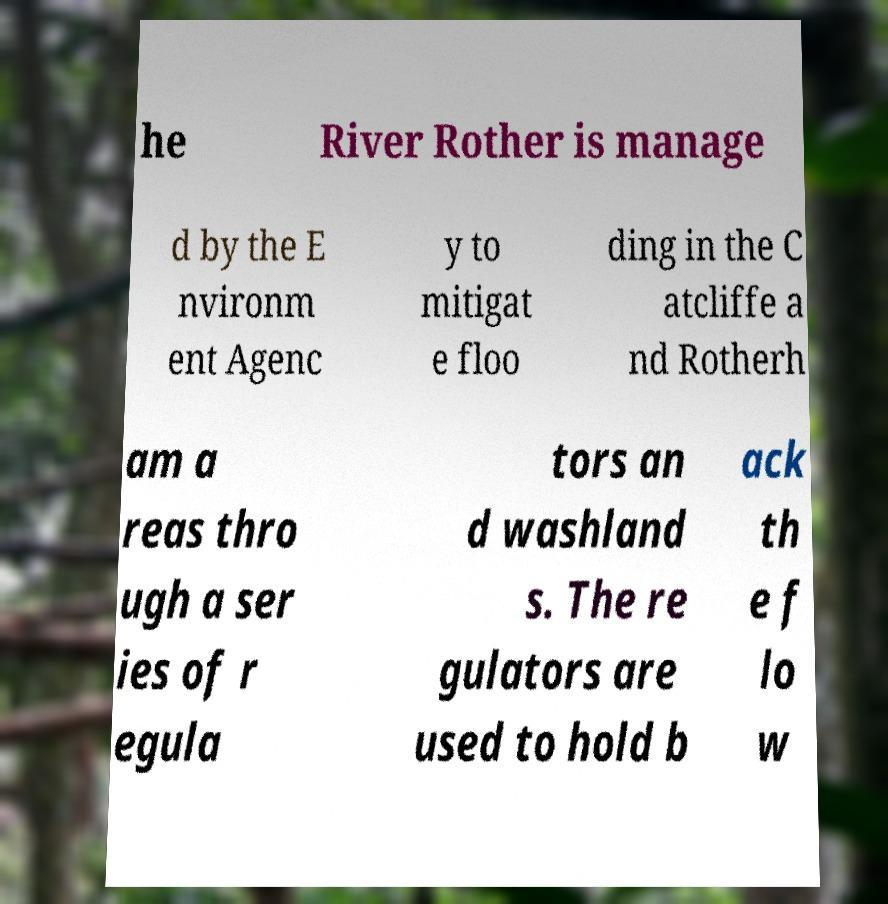Could you assist in decoding the text presented in this image and type it out clearly? he River Rother is manage d by the E nvironm ent Agenc y to mitigat e floo ding in the C atcliffe a nd Rotherh am a reas thro ugh a ser ies of r egula tors an d washland s. The re gulators are used to hold b ack th e f lo w 